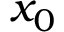Convert formula to latex. <formula><loc_0><loc_0><loc_500><loc_500>x _ { 0 }</formula> 